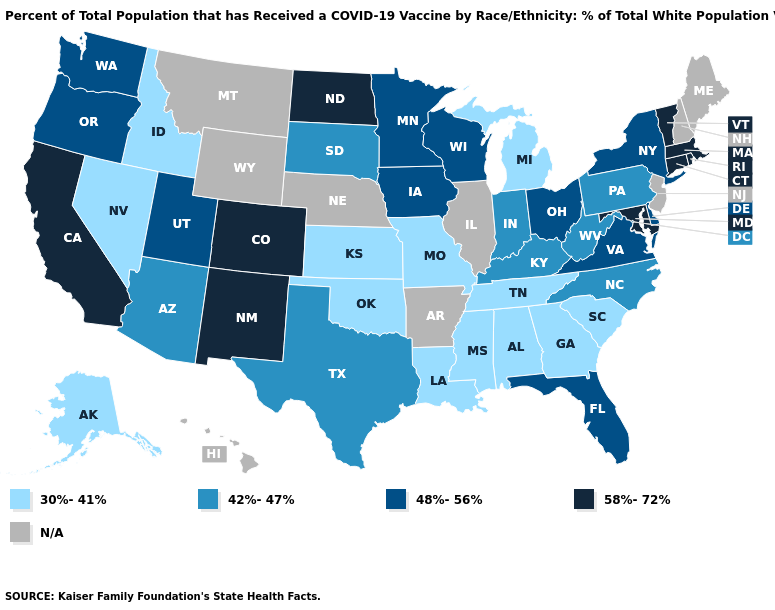Name the states that have a value in the range 48%-56%?
Answer briefly. Delaware, Florida, Iowa, Minnesota, New York, Ohio, Oregon, Utah, Virginia, Washington, Wisconsin. Among the states that border Michigan , does Indiana have the lowest value?
Answer briefly. Yes. Name the states that have a value in the range 42%-47%?
Answer briefly. Arizona, Indiana, Kentucky, North Carolina, Pennsylvania, South Dakota, Texas, West Virginia. What is the highest value in the USA?
Give a very brief answer. 58%-72%. What is the highest value in the USA?
Be succinct. 58%-72%. Name the states that have a value in the range 58%-72%?
Answer briefly. California, Colorado, Connecticut, Maryland, Massachusetts, New Mexico, North Dakota, Rhode Island, Vermont. Does the first symbol in the legend represent the smallest category?
Concise answer only. Yes. What is the value of Maine?
Answer briefly. N/A. Which states hav the highest value in the Northeast?
Quick response, please. Connecticut, Massachusetts, Rhode Island, Vermont. What is the lowest value in states that border Kansas?
Give a very brief answer. 30%-41%. What is the lowest value in states that border Texas?
Be succinct. 30%-41%. What is the highest value in the South ?
Write a very short answer. 58%-72%. Name the states that have a value in the range 58%-72%?
Short answer required. California, Colorado, Connecticut, Maryland, Massachusetts, New Mexico, North Dakota, Rhode Island, Vermont. Among the states that border Massachusetts , does Connecticut have the highest value?
Give a very brief answer. Yes. 